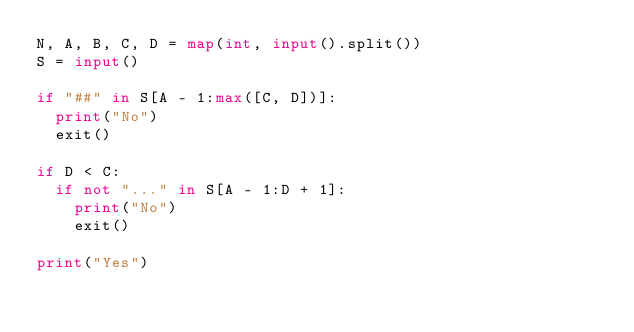Convert code to text. <code><loc_0><loc_0><loc_500><loc_500><_Python_>N, A, B, C, D = map(int, input().split())
S = input()

if "##" in S[A - 1:max([C, D])]:
	print("No")
	exit()

if D < C:
	if not "..." in S[A - 1:D + 1]:
		print("No")
		exit()

print("Yes")</code> 